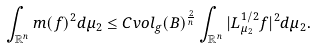<formula> <loc_0><loc_0><loc_500><loc_500>\int _ { \mathbb { R } ^ { n } } m ( f ) ^ { 2 } d \mu _ { 2 } \leq C v o l _ { g } ( B ) ^ { \frac { 2 } { n } } \int _ { \mathbb { R } ^ { n } } | L _ { \mu _ { 2 } } ^ { 1 / 2 } f | ^ { 2 } d \mu _ { 2 } .</formula> 